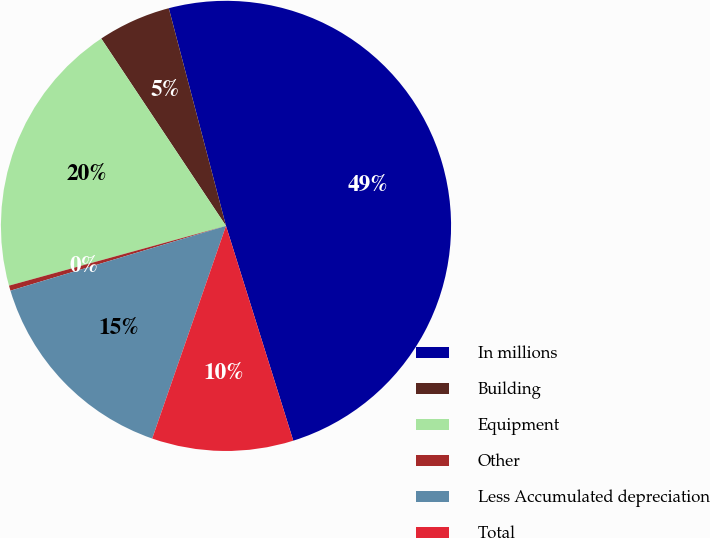Convert chart. <chart><loc_0><loc_0><loc_500><loc_500><pie_chart><fcel>In millions<fcel>Building<fcel>Equipment<fcel>Other<fcel>Less Accumulated depreciation<fcel>Total<nl><fcel>49.27%<fcel>5.26%<fcel>19.93%<fcel>0.37%<fcel>15.04%<fcel>10.15%<nl></chart> 